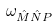Convert formula to latex. <formula><loc_0><loc_0><loc_500><loc_500>\omega _ { \hat { M } \hat { N } P }</formula> 